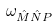Convert formula to latex. <formula><loc_0><loc_0><loc_500><loc_500>\omega _ { \hat { M } \hat { N } P }</formula> 